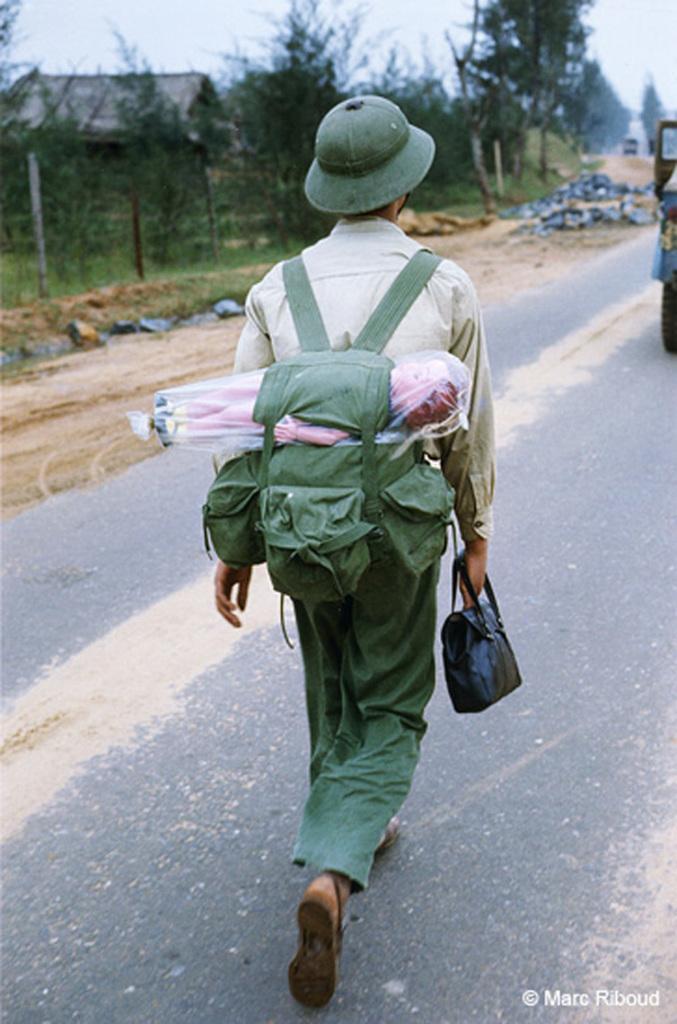Could you give a brief overview of what you see in this image? In this image, I can see a person holding a bag and walking on the road. In the background, I can see a house, trees, rocks and there is the sky. In the bottom right corner of the image, I can see a watermark. 